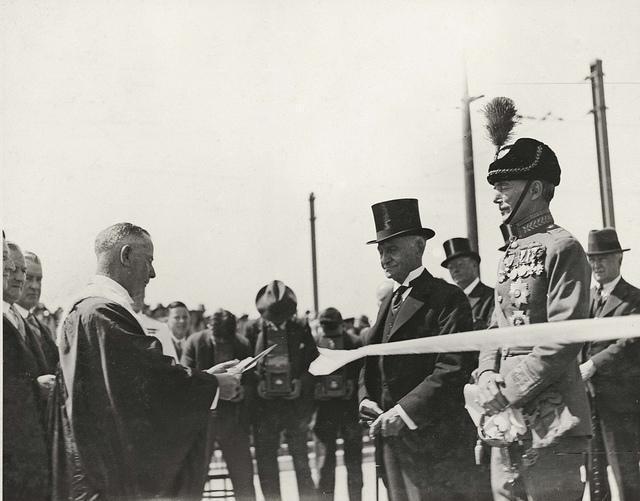How many people can be seen?
Give a very brief answer. 10. 